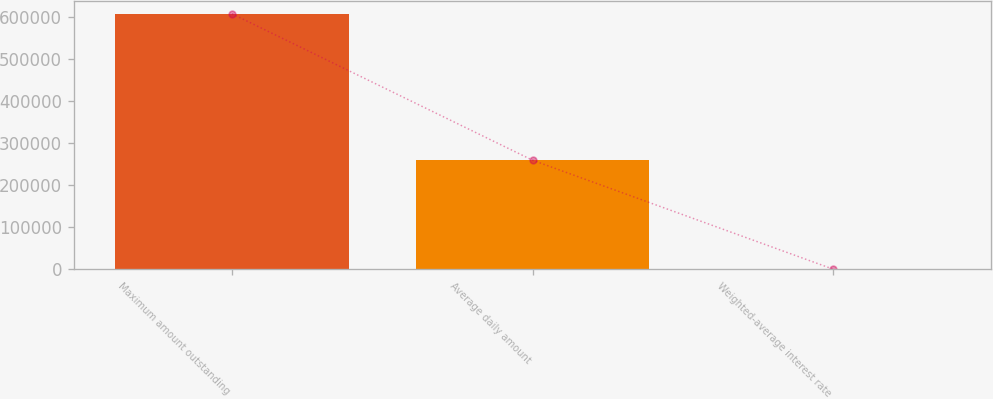Convert chart to OTSL. <chart><loc_0><loc_0><loc_500><loc_500><bar_chart><fcel>Maximum amount outstanding<fcel>Average daily amount<fcel>Weighted-average interest rate<nl><fcel>606753<fcel>258815<fcel>1.79<nl></chart> 